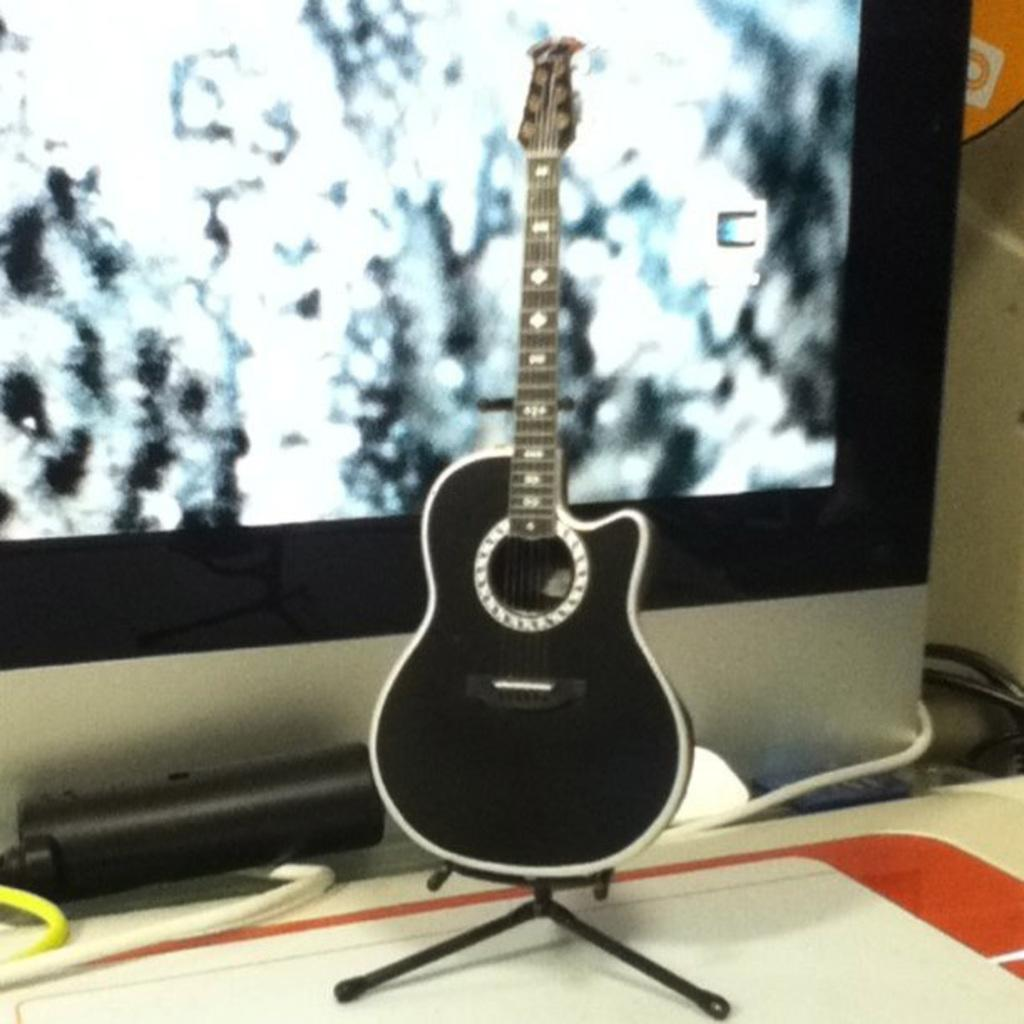What musical instrument is present in the image? There is a guitar in the image. How is the guitar positioned in the image? The guitar is placed on a stand. What electronic device is visible in the image? There is a digital screen visible in the image. What type of polish is being applied to the guitar in the image? There is no polish being applied to the guitar in the image; it is simply placed on a stand. How many apples are visible on the digital screen in the image? There are no apples visible on the digital screen in the image. 